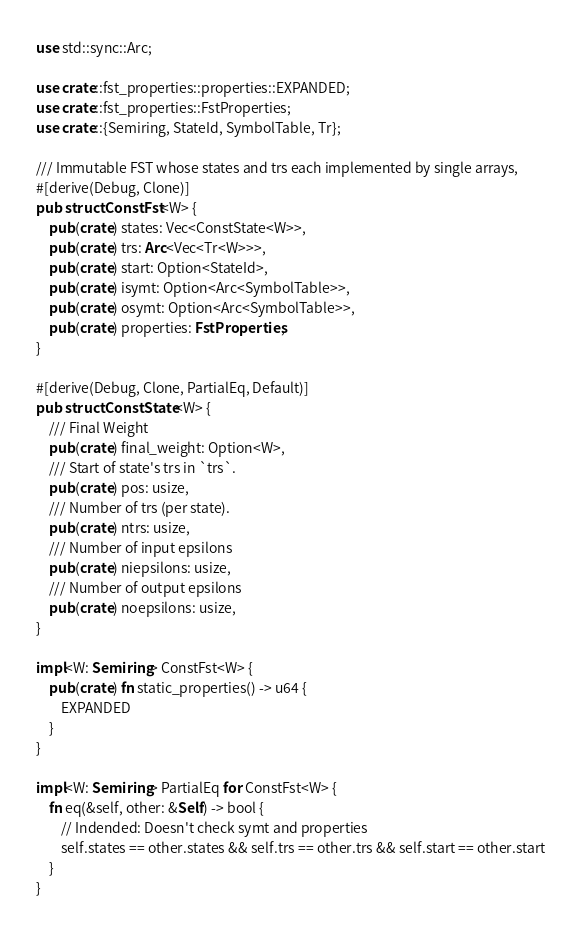Convert code to text. <code><loc_0><loc_0><loc_500><loc_500><_Rust_>use std::sync::Arc;

use crate::fst_properties::properties::EXPANDED;
use crate::fst_properties::FstProperties;
use crate::{Semiring, StateId, SymbolTable, Tr};

/// Immutable FST whose states and trs each implemented by single arrays,
#[derive(Debug, Clone)]
pub struct ConstFst<W> {
    pub(crate) states: Vec<ConstState<W>>,
    pub(crate) trs: Arc<Vec<Tr<W>>>,
    pub(crate) start: Option<StateId>,
    pub(crate) isymt: Option<Arc<SymbolTable>>,
    pub(crate) osymt: Option<Arc<SymbolTable>>,
    pub(crate) properties: FstProperties,
}

#[derive(Debug, Clone, PartialEq, Default)]
pub struct ConstState<W> {
    /// Final Weight
    pub(crate) final_weight: Option<W>,
    /// Start of state's trs in `trs`.
    pub(crate) pos: usize,
    /// Number of trs (per state).
    pub(crate) ntrs: usize,
    /// Number of input epsilons
    pub(crate) niepsilons: usize,
    /// Number of output epsilons
    pub(crate) noepsilons: usize,
}

impl<W: Semiring> ConstFst<W> {
    pub(crate) fn static_properties() -> u64 {
        EXPANDED
    }
}

impl<W: Semiring> PartialEq for ConstFst<W> {
    fn eq(&self, other: &Self) -> bool {
        // Indended: Doesn't check symt and properties
        self.states == other.states && self.trs == other.trs && self.start == other.start
    }
}
</code> 